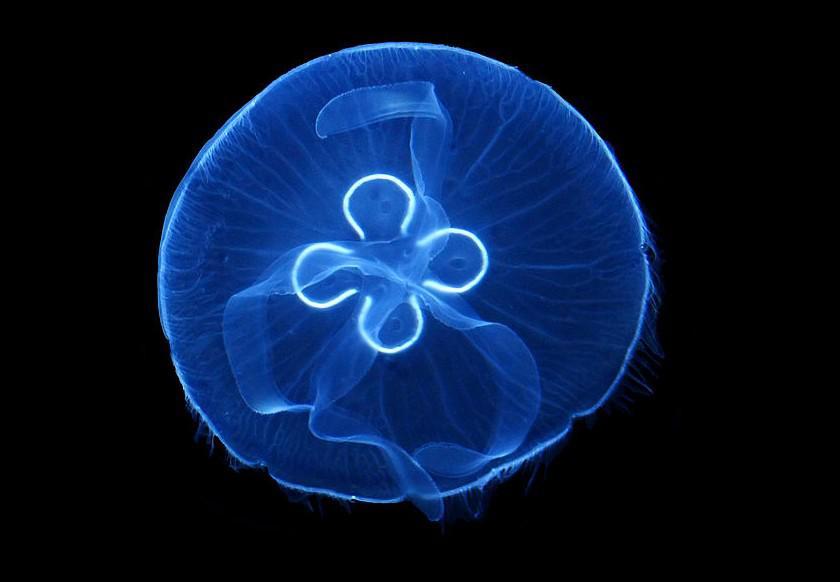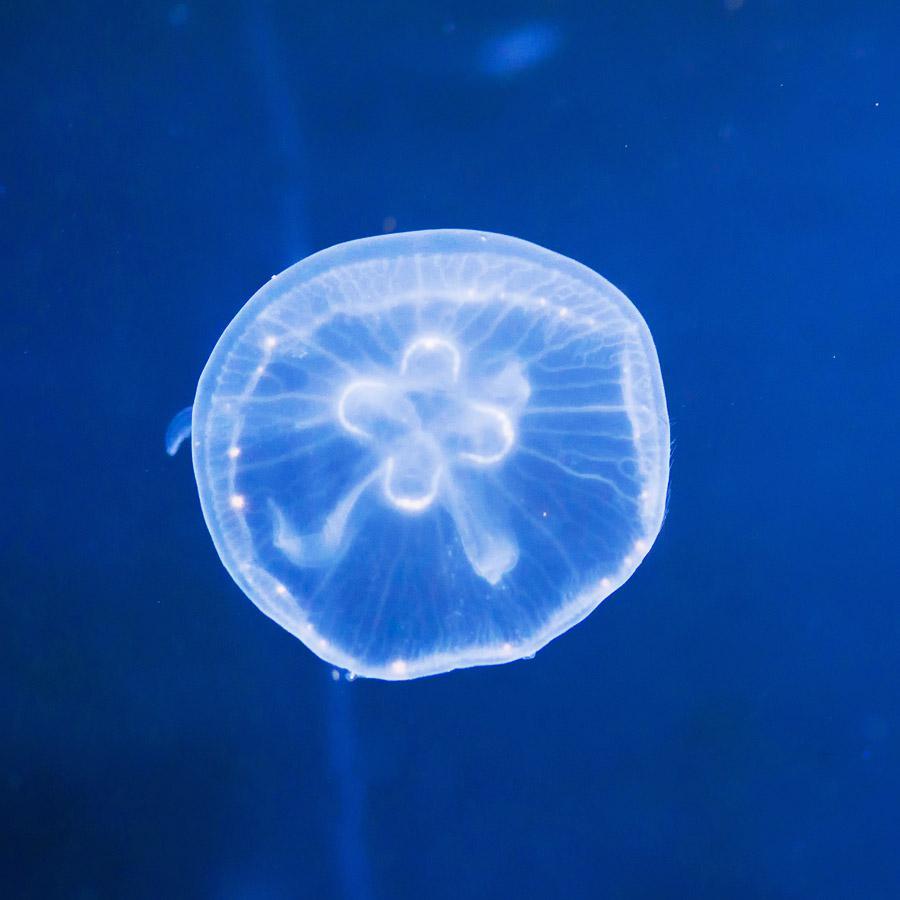The first image is the image on the left, the second image is the image on the right. Examine the images to the left and right. Is the description "At least one of the images has a purple tint to it; not just blue with tinges of orange." accurate? Answer yes or no. No. The first image is the image on the left, the second image is the image on the right. Considering the images on both sides, is "Each image includes one jellyfish viewed with its """"cap"""" head-on, showing something that resembles a neon-lit four-leaf clover." valid? Answer yes or no. Yes. 